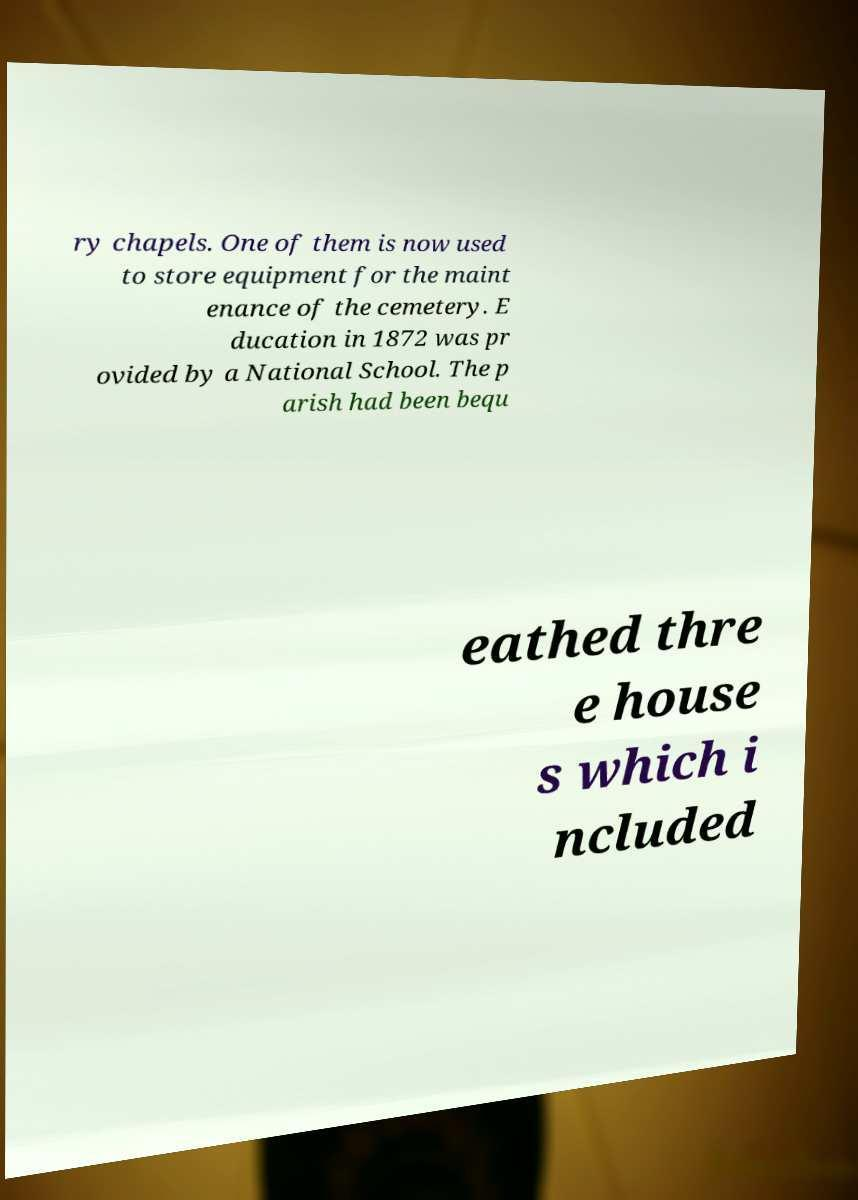Please identify and transcribe the text found in this image. ry chapels. One of them is now used to store equipment for the maint enance of the cemetery. E ducation in 1872 was pr ovided by a National School. The p arish had been bequ eathed thre e house s which i ncluded 